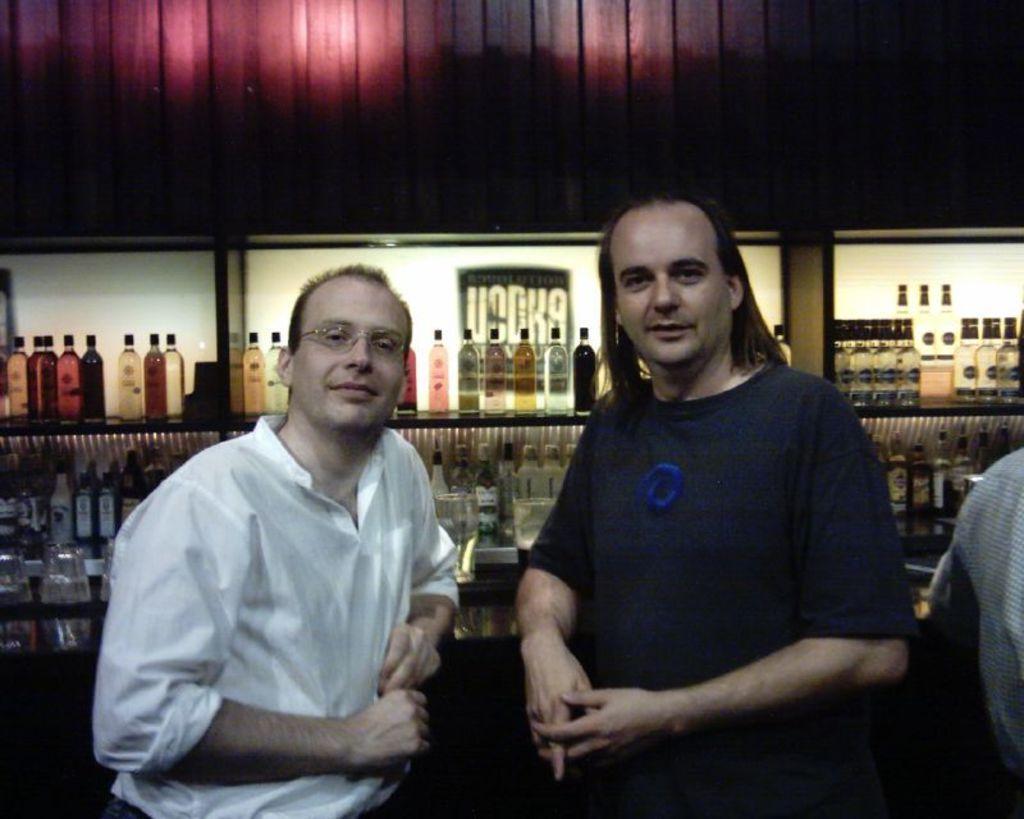In one or two sentences, can you explain what this image depicts? There are two persons standing as we can see at the bottom of this image. There are some bottles are kept in the racks in the background. 